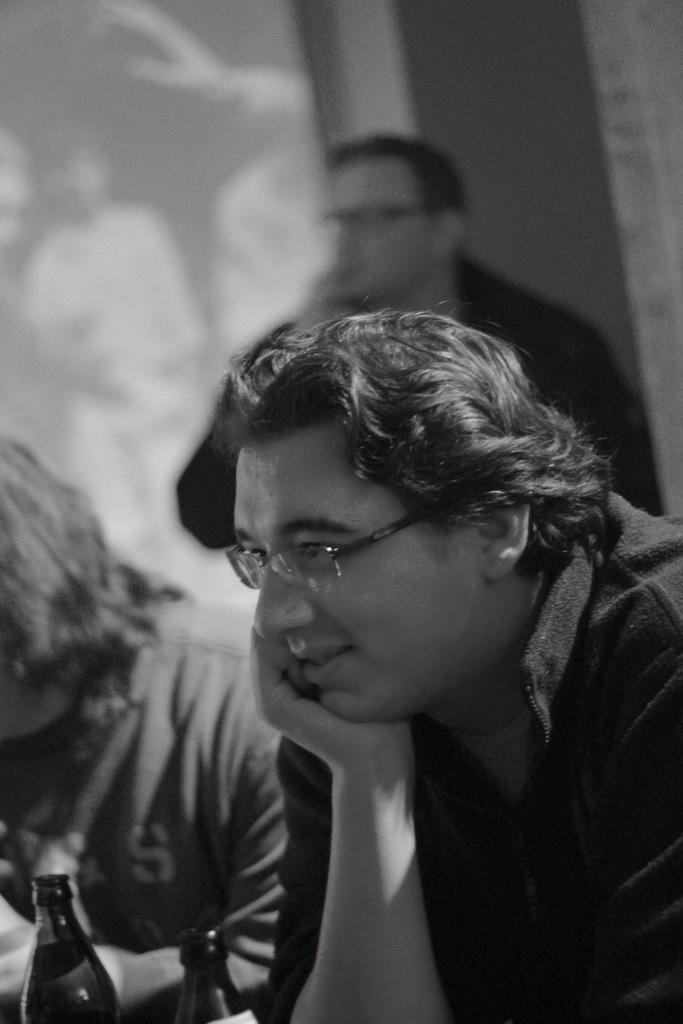Who or what is the main subject in the image? There is a person in the image. Can you describe the position of the person in the image? The person is standing in front. What is the color scheme of the image? The image is in black and white. What type of learning activity is the person participating in during the afternoon in the image? There is no indication of a learning activity or the time of day (afternoon) in the image, as it only features a person standing in front in black and white. 